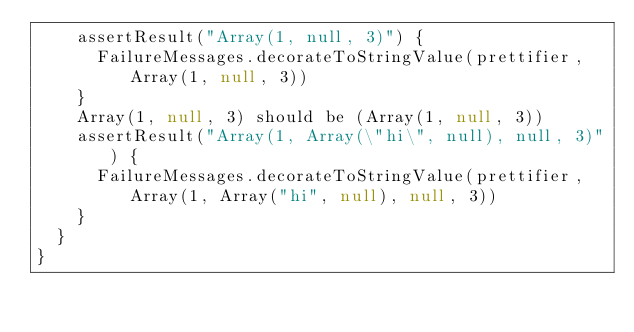Convert code to text. <code><loc_0><loc_0><loc_500><loc_500><_Scala_>    assertResult("Array(1, null, 3)") {
      FailureMessages.decorateToStringValue(prettifier, Array(1, null, 3))
    }
    Array(1, null, 3) should be (Array(1, null, 3))
    assertResult("Array(1, Array(\"hi\", null), null, 3)") {
      FailureMessages.decorateToStringValue(prettifier, Array(1, Array("hi", null), null, 3))
    }
  }
}
</code> 